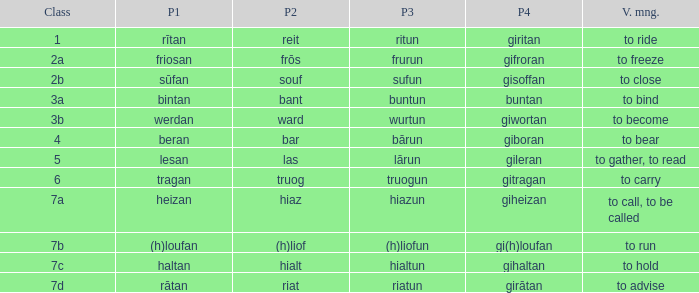What is the part 4 of the word with the part 1 "heizan"? Giheizan. 